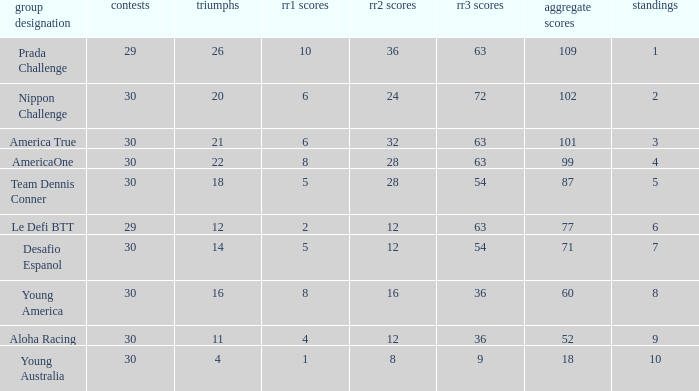Name the ranking for rr2 pts being 8 10.0. 